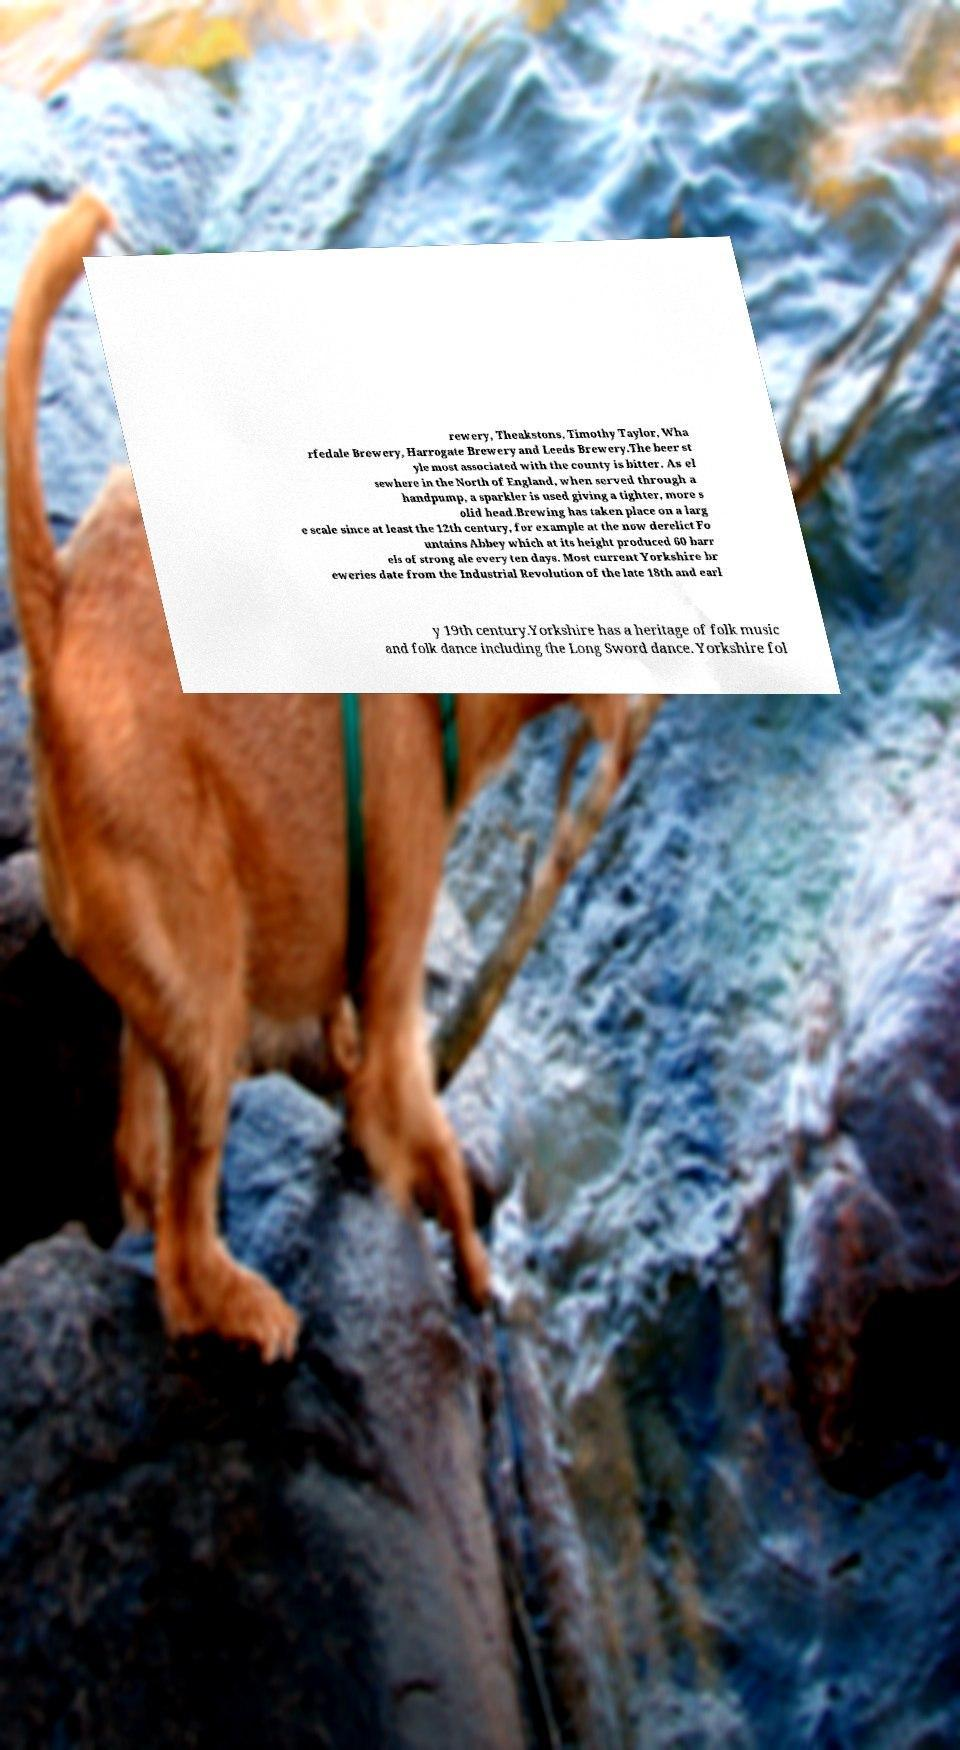Please read and relay the text visible in this image. What does it say? rewery, Theakstons, Timothy Taylor, Wha rfedale Brewery, Harrogate Brewery and Leeds Brewery.The beer st yle most associated with the county is bitter. As el sewhere in the North of England, when served through a handpump, a sparkler is used giving a tighter, more s olid head.Brewing has taken place on a larg e scale since at least the 12th century, for example at the now derelict Fo untains Abbey which at its height produced 60 barr els of strong ale every ten days. Most current Yorkshire br eweries date from the Industrial Revolution of the late 18th and earl y 19th century.Yorkshire has a heritage of folk music and folk dance including the Long Sword dance. Yorkshire fol 